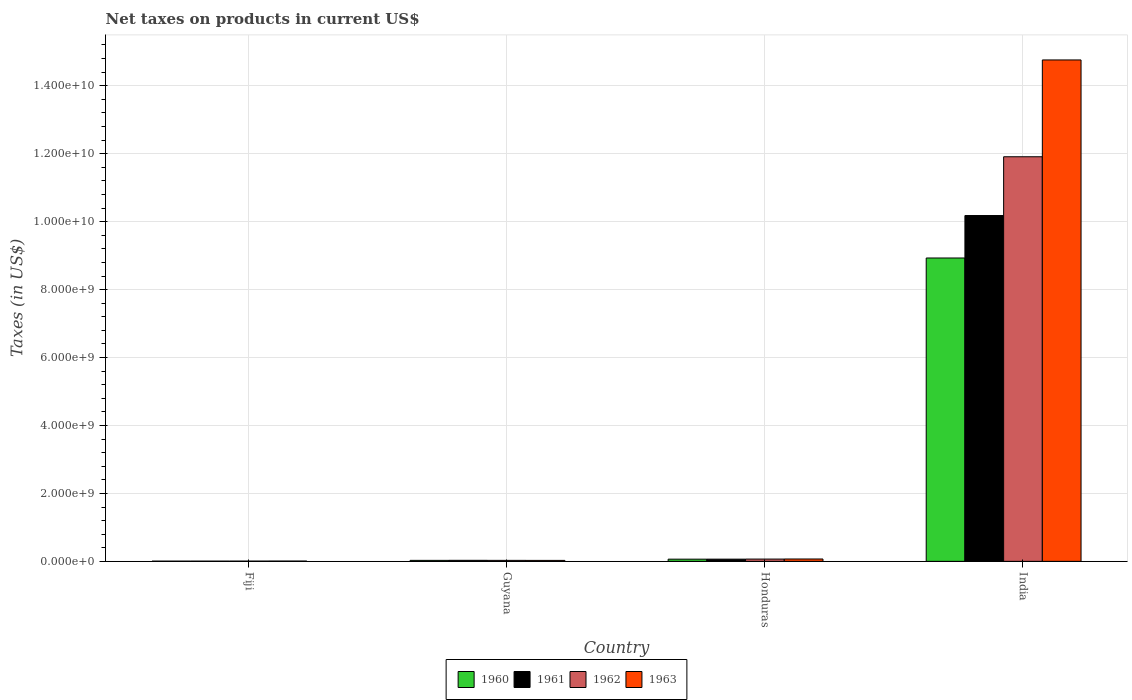Are the number of bars on each tick of the X-axis equal?
Make the answer very short. Yes. What is the label of the 4th group of bars from the left?
Offer a very short reply. India. In how many cases, is the number of bars for a given country not equal to the number of legend labels?
Give a very brief answer. 0. What is the net taxes on products in 1962 in India?
Provide a succinct answer. 1.19e+1. Across all countries, what is the maximum net taxes on products in 1961?
Provide a short and direct response. 1.02e+1. Across all countries, what is the minimum net taxes on products in 1961?
Offer a very short reply. 6.80e+06. In which country was the net taxes on products in 1963 maximum?
Your response must be concise. India. In which country was the net taxes on products in 1962 minimum?
Ensure brevity in your answer.  Fiji. What is the total net taxes on products in 1963 in the graph?
Give a very brief answer. 1.49e+1. What is the difference between the net taxes on products in 1961 in Guyana and that in India?
Provide a succinct answer. -1.01e+1. What is the difference between the net taxes on products in 1962 in Honduras and the net taxes on products in 1963 in India?
Provide a succinct answer. -1.47e+1. What is the average net taxes on products in 1960 per country?
Offer a terse response. 2.26e+09. What is the difference between the net taxes on products of/in 1962 and net taxes on products of/in 1960 in India?
Make the answer very short. 2.98e+09. What is the ratio of the net taxes on products in 1960 in Fiji to that in Honduras?
Give a very brief answer. 0.11. What is the difference between the highest and the second highest net taxes on products in 1961?
Offer a terse response. 1.01e+1. What is the difference between the highest and the lowest net taxes on products in 1960?
Provide a short and direct response. 8.92e+09. What does the 1st bar from the left in Fiji represents?
Offer a very short reply. 1960. Is it the case that in every country, the sum of the net taxes on products in 1963 and net taxes on products in 1962 is greater than the net taxes on products in 1961?
Provide a succinct answer. Yes. Does the graph contain any zero values?
Provide a short and direct response. No. What is the title of the graph?
Provide a succinct answer. Net taxes on products in current US$. What is the label or title of the Y-axis?
Offer a very short reply. Taxes (in US$). What is the Taxes (in US$) in 1960 in Fiji?
Give a very brief answer. 6.80e+06. What is the Taxes (in US$) of 1961 in Fiji?
Keep it short and to the point. 6.80e+06. What is the Taxes (in US$) in 1962 in Fiji?
Give a very brief answer. 7.40e+06. What is the Taxes (in US$) of 1963 in Fiji?
Your response must be concise. 8.90e+06. What is the Taxes (in US$) in 1960 in Guyana?
Ensure brevity in your answer.  2.94e+07. What is the Taxes (in US$) in 1961 in Guyana?
Give a very brief answer. 3.07e+07. What is the Taxes (in US$) of 1962 in Guyana?
Keep it short and to the point. 2.90e+07. What is the Taxes (in US$) of 1963 in Guyana?
Make the answer very short. 2.82e+07. What is the Taxes (in US$) of 1960 in Honduras?
Give a very brief answer. 6.45e+07. What is the Taxes (in US$) of 1961 in Honduras?
Your answer should be compact. 6.50e+07. What is the Taxes (in US$) in 1962 in Honduras?
Keep it short and to the point. 6.73e+07. What is the Taxes (in US$) of 1963 in Honduras?
Make the answer very short. 6.96e+07. What is the Taxes (in US$) in 1960 in India?
Offer a very short reply. 8.93e+09. What is the Taxes (in US$) in 1961 in India?
Your answer should be very brief. 1.02e+1. What is the Taxes (in US$) in 1962 in India?
Offer a terse response. 1.19e+1. What is the Taxes (in US$) in 1963 in India?
Provide a succinct answer. 1.48e+1. Across all countries, what is the maximum Taxes (in US$) in 1960?
Keep it short and to the point. 8.93e+09. Across all countries, what is the maximum Taxes (in US$) of 1961?
Provide a succinct answer. 1.02e+1. Across all countries, what is the maximum Taxes (in US$) of 1962?
Your response must be concise. 1.19e+1. Across all countries, what is the maximum Taxes (in US$) in 1963?
Offer a very short reply. 1.48e+1. Across all countries, what is the minimum Taxes (in US$) in 1960?
Give a very brief answer. 6.80e+06. Across all countries, what is the minimum Taxes (in US$) in 1961?
Offer a terse response. 6.80e+06. Across all countries, what is the minimum Taxes (in US$) of 1962?
Give a very brief answer. 7.40e+06. Across all countries, what is the minimum Taxes (in US$) in 1963?
Offer a terse response. 8.90e+06. What is the total Taxes (in US$) of 1960 in the graph?
Offer a terse response. 9.03e+09. What is the total Taxes (in US$) of 1961 in the graph?
Ensure brevity in your answer.  1.03e+1. What is the total Taxes (in US$) of 1962 in the graph?
Offer a terse response. 1.20e+1. What is the total Taxes (in US$) in 1963 in the graph?
Provide a short and direct response. 1.49e+1. What is the difference between the Taxes (in US$) in 1960 in Fiji and that in Guyana?
Ensure brevity in your answer.  -2.26e+07. What is the difference between the Taxes (in US$) in 1961 in Fiji and that in Guyana?
Keep it short and to the point. -2.39e+07. What is the difference between the Taxes (in US$) of 1962 in Fiji and that in Guyana?
Keep it short and to the point. -2.16e+07. What is the difference between the Taxes (in US$) of 1963 in Fiji and that in Guyana?
Provide a short and direct response. -1.93e+07. What is the difference between the Taxes (in US$) of 1960 in Fiji and that in Honduras?
Ensure brevity in your answer.  -5.77e+07. What is the difference between the Taxes (in US$) of 1961 in Fiji and that in Honduras?
Offer a very short reply. -5.82e+07. What is the difference between the Taxes (in US$) of 1962 in Fiji and that in Honduras?
Offer a very short reply. -5.99e+07. What is the difference between the Taxes (in US$) of 1963 in Fiji and that in Honduras?
Keep it short and to the point. -6.07e+07. What is the difference between the Taxes (in US$) of 1960 in Fiji and that in India?
Make the answer very short. -8.92e+09. What is the difference between the Taxes (in US$) of 1961 in Fiji and that in India?
Provide a succinct answer. -1.02e+1. What is the difference between the Taxes (in US$) of 1962 in Fiji and that in India?
Offer a very short reply. -1.19e+1. What is the difference between the Taxes (in US$) of 1963 in Fiji and that in India?
Give a very brief answer. -1.48e+1. What is the difference between the Taxes (in US$) in 1960 in Guyana and that in Honduras?
Make the answer very short. -3.51e+07. What is the difference between the Taxes (in US$) in 1961 in Guyana and that in Honduras?
Give a very brief answer. -3.43e+07. What is the difference between the Taxes (in US$) of 1962 in Guyana and that in Honduras?
Provide a short and direct response. -3.83e+07. What is the difference between the Taxes (in US$) of 1963 in Guyana and that in Honduras?
Ensure brevity in your answer.  -4.14e+07. What is the difference between the Taxes (in US$) of 1960 in Guyana and that in India?
Make the answer very short. -8.90e+09. What is the difference between the Taxes (in US$) in 1961 in Guyana and that in India?
Your answer should be compact. -1.01e+1. What is the difference between the Taxes (in US$) in 1962 in Guyana and that in India?
Your response must be concise. -1.19e+1. What is the difference between the Taxes (in US$) in 1963 in Guyana and that in India?
Your answer should be compact. -1.47e+1. What is the difference between the Taxes (in US$) of 1960 in Honduras and that in India?
Keep it short and to the point. -8.87e+09. What is the difference between the Taxes (in US$) in 1961 in Honduras and that in India?
Keep it short and to the point. -1.01e+1. What is the difference between the Taxes (in US$) of 1962 in Honduras and that in India?
Provide a short and direct response. -1.18e+1. What is the difference between the Taxes (in US$) of 1963 in Honduras and that in India?
Provide a succinct answer. -1.47e+1. What is the difference between the Taxes (in US$) in 1960 in Fiji and the Taxes (in US$) in 1961 in Guyana?
Provide a short and direct response. -2.39e+07. What is the difference between the Taxes (in US$) in 1960 in Fiji and the Taxes (in US$) in 1962 in Guyana?
Provide a succinct answer. -2.22e+07. What is the difference between the Taxes (in US$) in 1960 in Fiji and the Taxes (in US$) in 1963 in Guyana?
Ensure brevity in your answer.  -2.14e+07. What is the difference between the Taxes (in US$) in 1961 in Fiji and the Taxes (in US$) in 1962 in Guyana?
Your response must be concise. -2.22e+07. What is the difference between the Taxes (in US$) of 1961 in Fiji and the Taxes (in US$) of 1963 in Guyana?
Ensure brevity in your answer.  -2.14e+07. What is the difference between the Taxes (in US$) of 1962 in Fiji and the Taxes (in US$) of 1963 in Guyana?
Your answer should be compact. -2.08e+07. What is the difference between the Taxes (in US$) in 1960 in Fiji and the Taxes (in US$) in 1961 in Honduras?
Give a very brief answer. -5.82e+07. What is the difference between the Taxes (in US$) in 1960 in Fiji and the Taxes (in US$) in 1962 in Honduras?
Your answer should be very brief. -6.05e+07. What is the difference between the Taxes (in US$) of 1960 in Fiji and the Taxes (in US$) of 1963 in Honduras?
Your answer should be very brief. -6.28e+07. What is the difference between the Taxes (in US$) of 1961 in Fiji and the Taxes (in US$) of 1962 in Honduras?
Your response must be concise. -6.05e+07. What is the difference between the Taxes (in US$) in 1961 in Fiji and the Taxes (in US$) in 1963 in Honduras?
Offer a terse response. -6.28e+07. What is the difference between the Taxes (in US$) in 1962 in Fiji and the Taxes (in US$) in 1963 in Honduras?
Your answer should be very brief. -6.22e+07. What is the difference between the Taxes (in US$) in 1960 in Fiji and the Taxes (in US$) in 1961 in India?
Keep it short and to the point. -1.02e+1. What is the difference between the Taxes (in US$) of 1960 in Fiji and the Taxes (in US$) of 1962 in India?
Your answer should be very brief. -1.19e+1. What is the difference between the Taxes (in US$) of 1960 in Fiji and the Taxes (in US$) of 1963 in India?
Your answer should be very brief. -1.48e+1. What is the difference between the Taxes (in US$) of 1961 in Fiji and the Taxes (in US$) of 1962 in India?
Keep it short and to the point. -1.19e+1. What is the difference between the Taxes (in US$) of 1961 in Fiji and the Taxes (in US$) of 1963 in India?
Provide a succinct answer. -1.48e+1. What is the difference between the Taxes (in US$) in 1962 in Fiji and the Taxes (in US$) in 1963 in India?
Ensure brevity in your answer.  -1.48e+1. What is the difference between the Taxes (in US$) of 1960 in Guyana and the Taxes (in US$) of 1961 in Honduras?
Make the answer very short. -3.56e+07. What is the difference between the Taxes (in US$) of 1960 in Guyana and the Taxes (in US$) of 1962 in Honduras?
Give a very brief answer. -3.79e+07. What is the difference between the Taxes (in US$) in 1960 in Guyana and the Taxes (in US$) in 1963 in Honduras?
Your answer should be compact. -4.02e+07. What is the difference between the Taxes (in US$) in 1961 in Guyana and the Taxes (in US$) in 1962 in Honduras?
Your response must be concise. -3.66e+07. What is the difference between the Taxes (in US$) in 1961 in Guyana and the Taxes (in US$) in 1963 in Honduras?
Provide a succinct answer. -3.89e+07. What is the difference between the Taxes (in US$) in 1962 in Guyana and the Taxes (in US$) in 1963 in Honduras?
Your response must be concise. -4.06e+07. What is the difference between the Taxes (in US$) of 1960 in Guyana and the Taxes (in US$) of 1961 in India?
Keep it short and to the point. -1.02e+1. What is the difference between the Taxes (in US$) in 1960 in Guyana and the Taxes (in US$) in 1962 in India?
Your response must be concise. -1.19e+1. What is the difference between the Taxes (in US$) in 1960 in Guyana and the Taxes (in US$) in 1963 in India?
Provide a short and direct response. -1.47e+1. What is the difference between the Taxes (in US$) of 1961 in Guyana and the Taxes (in US$) of 1962 in India?
Your answer should be very brief. -1.19e+1. What is the difference between the Taxes (in US$) in 1961 in Guyana and the Taxes (in US$) in 1963 in India?
Provide a short and direct response. -1.47e+1. What is the difference between the Taxes (in US$) in 1962 in Guyana and the Taxes (in US$) in 1963 in India?
Keep it short and to the point. -1.47e+1. What is the difference between the Taxes (in US$) of 1960 in Honduras and the Taxes (in US$) of 1961 in India?
Keep it short and to the point. -1.01e+1. What is the difference between the Taxes (in US$) in 1960 in Honduras and the Taxes (in US$) in 1962 in India?
Your answer should be very brief. -1.18e+1. What is the difference between the Taxes (in US$) in 1960 in Honduras and the Taxes (in US$) in 1963 in India?
Your response must be concise. -1.47e+1. What is the difference between the Taxes (in US$) in 1961 in Honduras and the Taxes (in US$) in 1962 in India?
Ensure brevity in your answer.  -1.18e+1. What is the difference between the Taxes (in US$) of 1961 in Honduras and the Taxes (in US$) of 1963 in India?
Make the answer very short. -1.47e+1. What is the difference between the Taxes (in US$) in 1962 in Honduras and the Taxes (in US$) in 1963 in India?
Give a very brief answer. -1.47e+1. What is the average Taxes (in US$) in 1960 per country?
Your response must be concise. 2.26e+09. What is the average Taxes (in US$) of 1961 per country?
Your answer should be compact. 2.57e+09. What is the average Taxes (in US$) of 1962 per country?
Provide a succinct answer. 3.00e+09. What is the average Taxes (in US$) in 1963 per country?
Make the answer very short. 3.72e+09. What is the difference between the Taxes (in US$) of 1960 and Taxes (in US$) of 1961 in Fiji?
Your answer should be compact. 0. What is the difference between the Taxes (in US$) of 1960 and Taxes (in US$) of 1962 in Fiji?
Keep it short and to the point. -6.00e+05. What is the difference between the Taxes (in US$) of 1960 and Taxes (in US$) of 1963 in Fiji?
Give a very brief answer. -2.10e+06. What is the difference between the Taxes (in US$) of 1961 and Taxes (in US$) of 1962 in Fiji?
Your answer should be very brief. -6.00e+05. What is the difference between the Taxes (in US$) of 1961 and Taxes (in US$) of 1963 in Fiji?
Your answer should be very brief. -2.10e+06. What is the difference between the Taxes (in US$) of 1962 and Taxes (in US$) of 1963 in Fiji?
Ensure brevity in your answer.  -1.50e+06. What is the difference between the Taxes (in US$) of 1960 and Taxes (in US$) of 1961 in Guyana?
Offer a very short reply. -1.30e+06. What is the difference between the Taxes (in US$) of 1960 and Taxes (in US$) of 1963 in Guyana?
Your answer should be very brief. 1.20e+06. What is the difference between the Taxes (in US$) in 1961 and Taxes (in US$) in 1962 in Guyana?
Ensure brevity in your answer.  1.70e+06. What is the difference between the Taxes (in US$) in 1961 and Taxes (in US$) in 1963 in Guyana?
Your answer should be compact. 2.50e+06. What is the difference between the Taxes (in US$) of 1962 and Taxes (in US$) of 1963 in Guyana?
Ensure brevity in your answer.  8.00e+05. What is the difference between the Taxes (in US$) in 1960 and Taxes (in US$) in 1961 in Honduras?
Make the answer very short. -5.00e+05. What is the difference between the Taxes (in US$) in 1960 and Taxes (in US$) in 1962 in Honduras?
Ensure brevity in your answer.  -2.80e+06. What is the difference between the Taxes (in US$) in 1960 and Taxes (in US$) in 1963 in Honduras?
Your answer should be compact. -5.10e+06. What is the difference between the Taxes (in US$) in 1961 and Taxes (in US$) in 1962 in Honduras?
Offer a terse response. -2.30e+06. What is the difference between the Taxes (in US$) of 1961 and Taxes (in US$) of 1963 in Honduras?
Give a very brief answer. -4.60e+06. What is the difference between the Taxes (in US$) in 1962 and Taxes (in US$) in 1963 in Honduras?
Offer a terse response. -2.30e+06. What is the difference between the Taxes (in US$) of 1960 and Taxes (in US$) of 1961 in India?
Ensure brevity in your answer.  -1.25e+09. What is the difference between the Taxes (in US$) in 1960 and Taxes (in US$) in 1962 in India?
Make the answer very short. -2.98e+09. What is the difference between the Taxes (in US$) in 1960 and Taxes (in US$) in 1963 in India?
Your response must be concise. -5.83e+09. What is the difference between the Taxes (in US$) in 1961 and Taxes (in US$) in 1962 in India?
Keep it short and to the point. -1.73e+09. What is the difference between the Taxes (in US$) of 1961 and Taxes (in US$) of 1963 in India?
Provide a short and direct response. -4.58e+09. What is the difference between the Taxes (in US$) of 1962 and Taxes (in US$) of 1963 in India?
Keep it short and to the point. -2.85e+09. What is the ratio of the Taxes (in US$) in 1960 in Fiji to that in Guyana?
Offer a very short reply. 0.23. What is the ratio of the Taxes (in US$) of 1961 in Fiji to that in Guyana?
Your answer should be very brief. 0.22. What is the ratio of the Taxes (in US$) in 1962 in Fiji to that in Guyana?
Keep it short and to the point. 0.26. What is the ratio of the Taxes (in US$) of 1963 in Fiji to that in Guyana?
Give a very brief answer. 0.32. What is the ratio of the Taxes (in US$) in 1960 in Fiji to that in Honduras?
Keep it short and to the point. 0.11. What is the ratio of the Taxes (in US$) of 1961 in Fiji to that in Honduras?
Keep it short and to the point. 0.1. What is the ratio of the Taxes (in US$) in 1962 in Fiji to that in Honduras?
Ensure brevity in your answer.  0.11. What is the ratio of the Taxes (in US$) of 1963 in Fiji to that in Honduras?
Offer a very short reply. 0.13. What is the ratio of the Taxes (in US$) in 1960 in Fiji to that in India?
Provide a short and direct response. 0. What is the ratio of the Taxes (in US$) in 1961 in Fiji to that in India?
Make the answer very short. 0. What is the ratio of the Taxes (in US$) of 1962 in Fiji to that in India?
Provide a succinct answer. 0. What is the ratio of the Taxes (in US$) in 1963 in Fiji to that in India?
Your answer should be very brief. 0. What is the ratio of the Taxes (in US$) in 1960 in Guyana to that in Honduras?
Offer a terse response. 0.46. What is the ratio of the Taxes (in US$) in 1961 in Guyana to that in Honduras?
Provide a succinct answer. 0.47. What is the ratio of the Taxes (in US$) in 1962 in Guyana to that in Honduras?
Provide a short and direct response. 0.43. What is the ratio of the Taxes (in US$) of 1963 in Guyana to that in Honduras?
Provide a short and direct response. 0.41. What is the ratio of the Taxes (in US$) in 1960 in Guyana to that in India?
Make the answer very short. 0. What is the ratio of the Taxes (in US$) of 1961 in Guyana to that in India?
Your response must be concise. 0. What is the ratio of the Taxes (in US$) of 1962 in Guyana to that in India?
Ensure brevity in your answer.  0. What is the ratio of the Taxes (in US$) of 1963 in Guyana to that in India?
Your answer should be very brief. 0. What is the ratio of the Taxes (in US$) in 1960 in Honduras to that in India?
Provide a succinct answer. 0.01. What is the ratio of the Taxes (in US$) in 1961 in Honduras to that in India?
Provide a succinct answer. 0.01. What is the ratio of the Taxes (in US$) in 1962 in Honduras to that in India?
Give a very brief answer. 0.01. What is the ratio of the Taxes (in US$) in 1963 in Honduras to that in India?
Provide a short and direct response. 0. What is the difference between the highest and the second highest Taxes (in US$) of 1960?
Make the answer very short. 8.87e+09. What is the difference between the highest and the second highest Taxes (in US$) of 1961?
Provide a succinct answer. 1.01e+1. What is the difference between the highest and the second highest Taxes (in US$) of 1962?
Your response must be concise. 1.18e+1. What is the difference between the highest and the second highest Taxes (in US$) of 1963?
Your response must be concise. 1.47e+1. What is the difference between the highest and the lowest Taxes (in US$) of 1960?
Offer a terse response. 8.92e+09. What is the difference between the highest and the lowest Taxes (in US$) of 1961?
Make the answer very short. 1.02e+1. What is the difference between the highest and the lowest Taxes (in US$) in 1962?
Ensure brevity in your answer.  1.19e+1. What is the difference between the highest and the lowest Taxes (in US$) in 1963?
Your answer should be compact. 1.48e+1. 